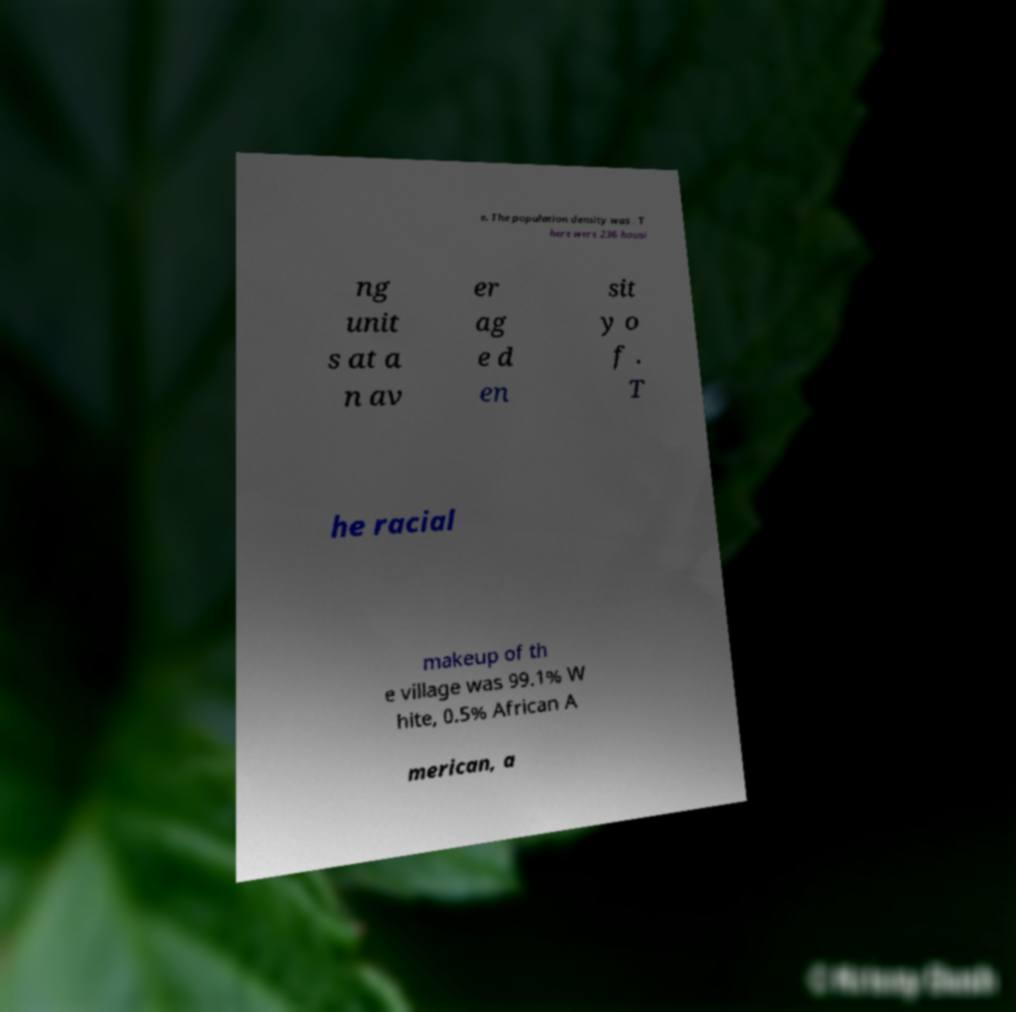Can you read and provide the text displayed in the image?This photo seems to have some interesting text. Can you extract and type it out for me? e. The population density was . T here were 236 housi ng unit s at a n av er ag e d en sit y o f . T he racial makeup of th e village was 99.1% W hite, 0.5% African A merican, a 